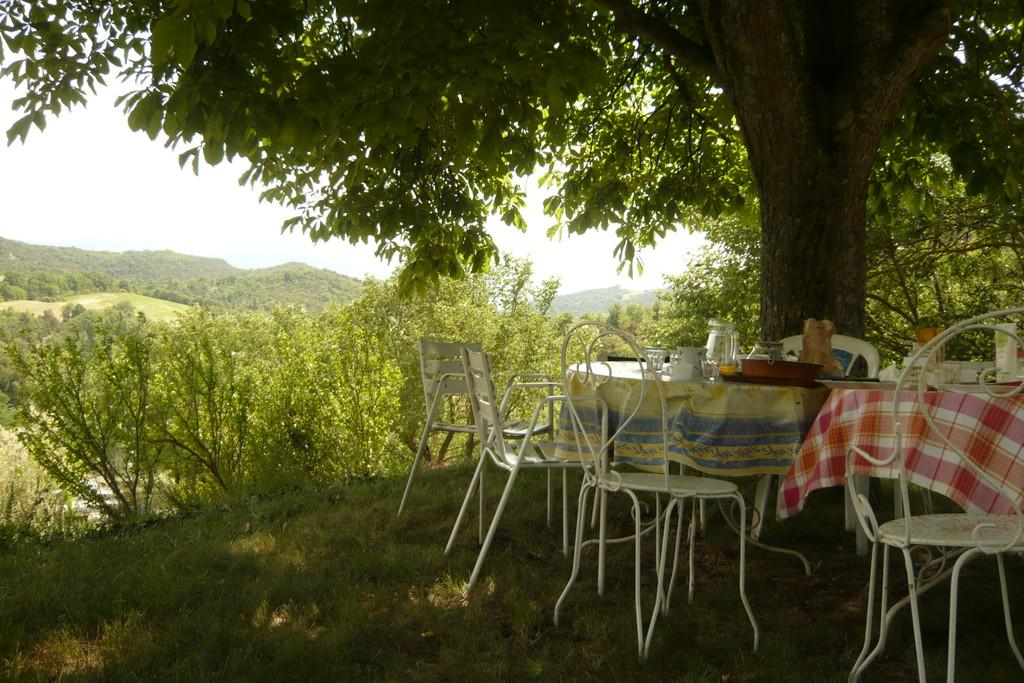What type of furniture is present in the image? There are chairs in the image. What can be found on the tables in the image? There are bowls and jars on the tables. What can be seen in the background of the image? There is grass, a group of trees, mountains, and the sky visible in the background of the image. How many eggs are being used in the war depicted in the image? There is no war or eggs present in the image. What type of creature is biting the chair in the image? There is no creature biting the chair in the image; it is a still image of chairs, tables, and other objects. 